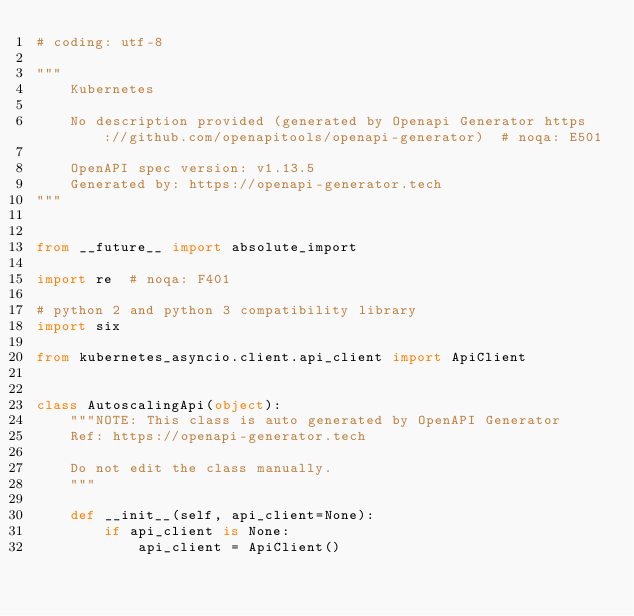<code> <loc_0><loc_0><loc_500><loc_500><_Python_># coding: utf-8

"""
    Kubernetes

    No description provided (generated by Openapi Generator https://github.com/openapitools/openapi-generator)  # noqa: E501

    OpenAPI spec version: v1.13.5
    Generated by: https://openapi-generator.tech
"""


from __future__ import absolute_import

import re  # noqa: F401

# python 2 and python 3 compatibility library
import six

from kubernetes_asyncio.client.api_client import ApiClient


class AutoscalingApi(object):
    """NOTE: This class is auto generated by OpenAPI Generator
    Ref: https://openapi-generator.tech

    Do not edit the class manually.
    """

    def __init__(self, api_client=None):
        if api_client is None:
            api_client = ApiClient()</code> 